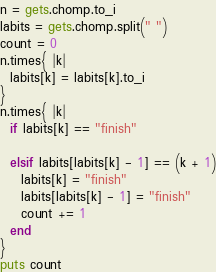<code> <loc_0><loc_0><loc_500><loc_500><_Ruby_>n = gets.chomp.to_i
labits = gets.chomp.split(" ")
count = 0
n.times{ |k|
  labits[k] = labits[k].to_i
}
n.times{ |k|
  if labits[k] == "finish"
    
  elsif labits[labits[k] - 1] == (k + 1)
    labits[k] = "finish"
    labits[labits[k] - 1] = "finish"
    count += 1
  end
}
puts count</code> 